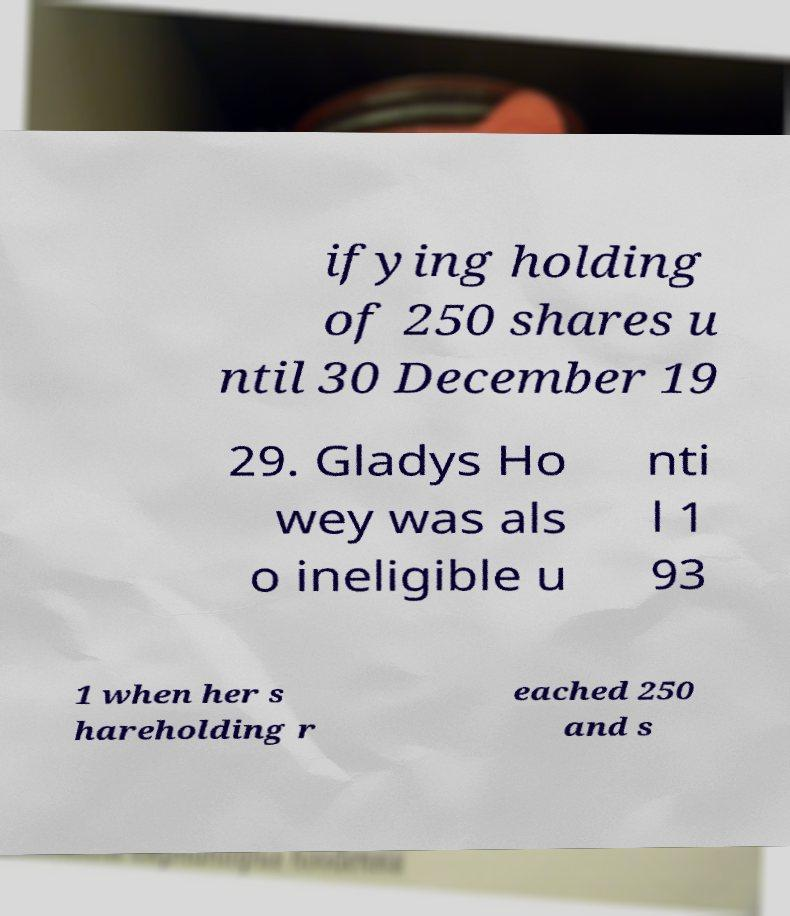Please identify and transcribe the text found in this image. ifying holding of 250 shares u ntil 30 December 19 29. Gladys Ho wey was als o ineligible u nti l 1 93 1 when her s hareholding r eached 250 and s 